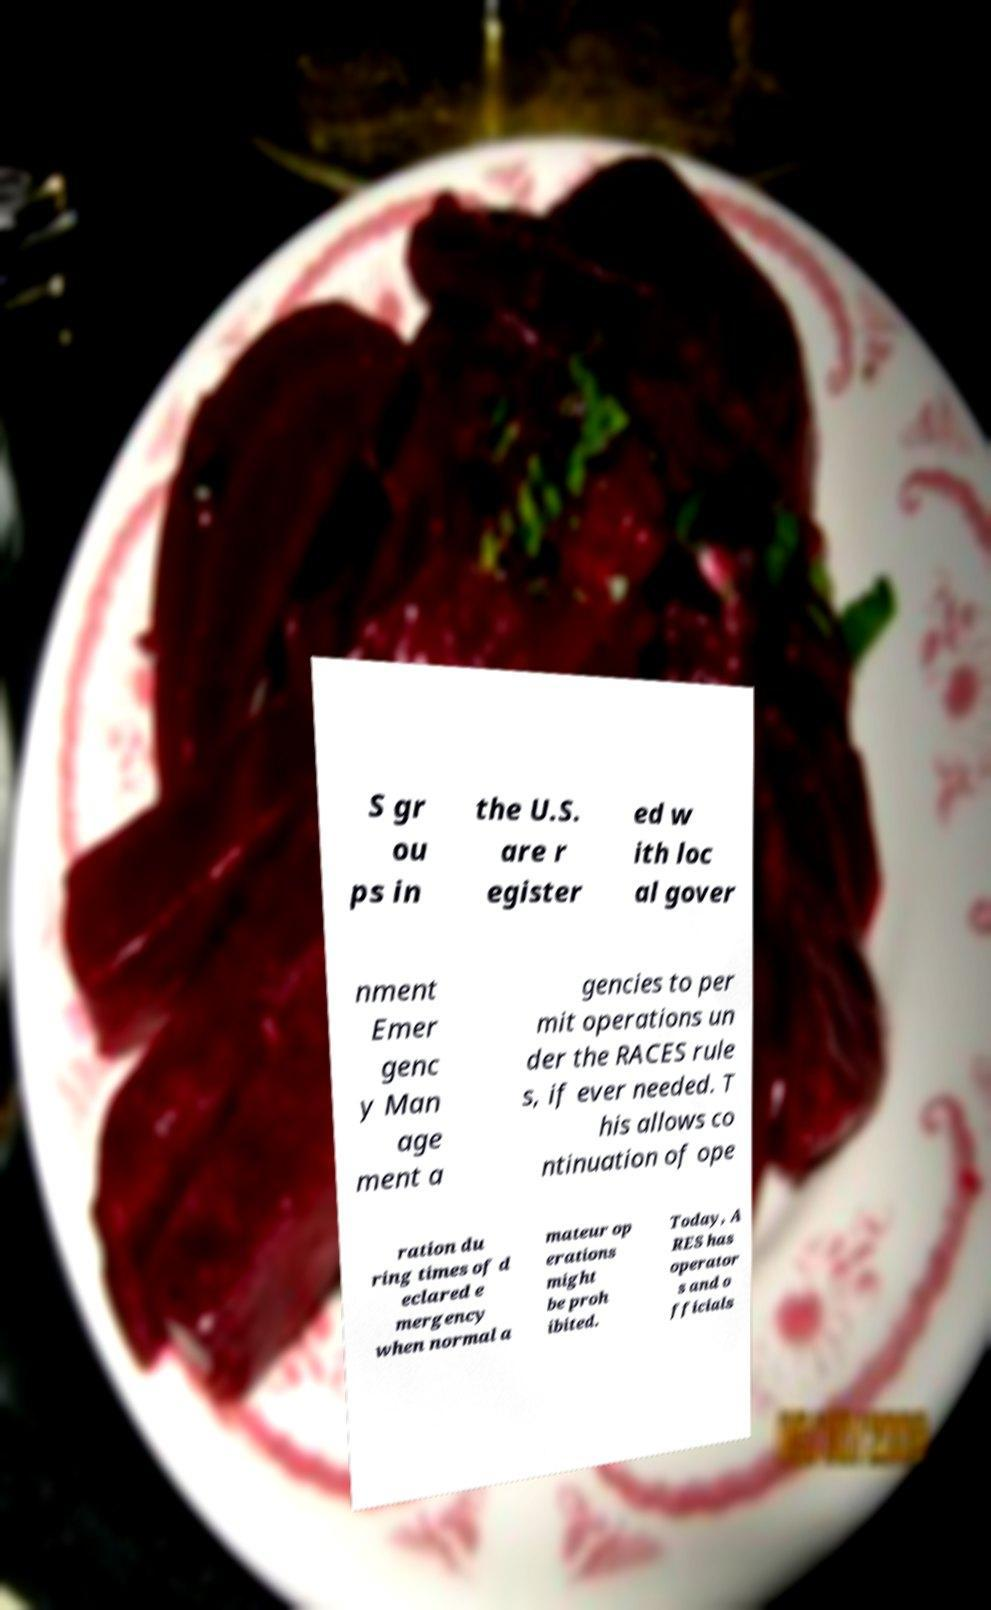Could you assist in decoding the text presented in this image and type it out clearly? S gr ou ps in the U.S. are r egister ed w ith loc al gover nment Emer genc y Man age ment a gencies to per mit operations un der the RACES rule s, if ever needed. T his allows co ntinuation of ope ration du ring times of d eclared e mergency when normal a mateur op erations might be proh ibited. Today, A RES has operator s and o fficials 